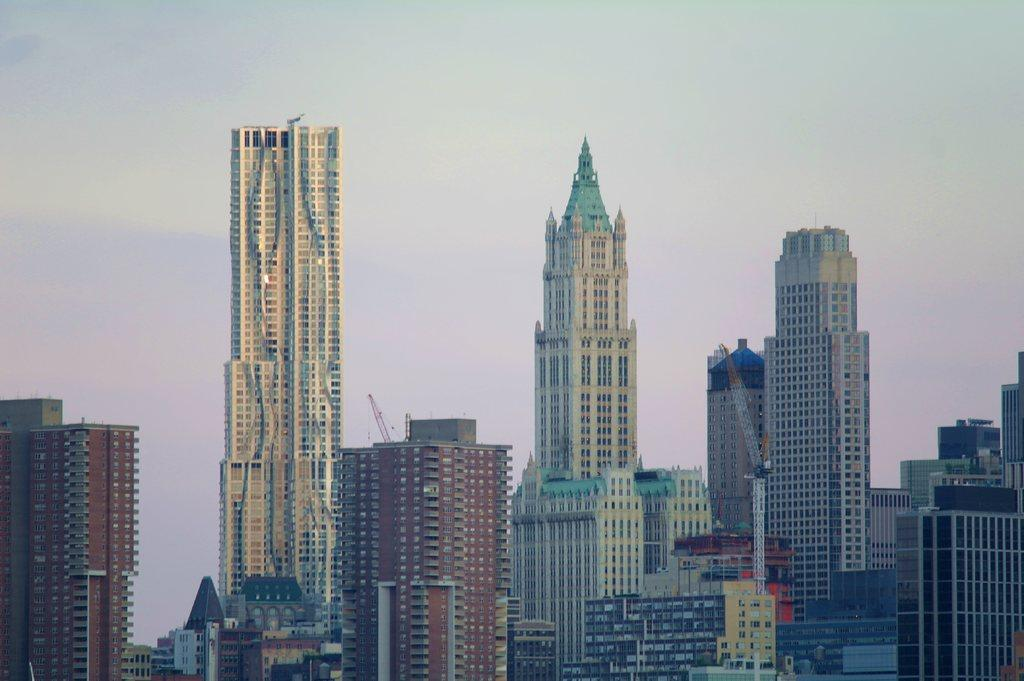What structures are located in the foreground of the image? There are buildings in the foreground of the image. Can you describe the background of the image? The sky is visible in the background of the image. What type of leather can be seen on the buildings in the image? There is no leather present on the buildings in the image; they are made of other materials. 